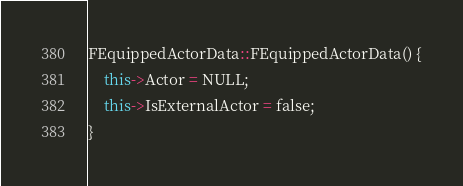<code> <loc_0><loc_0><loc_500><loc_500><_C++_>FEquippedActorData::FEquippedActorData() {
    this->Actor = NULL;
    this->IsExternalActor = false;
}

</code> 